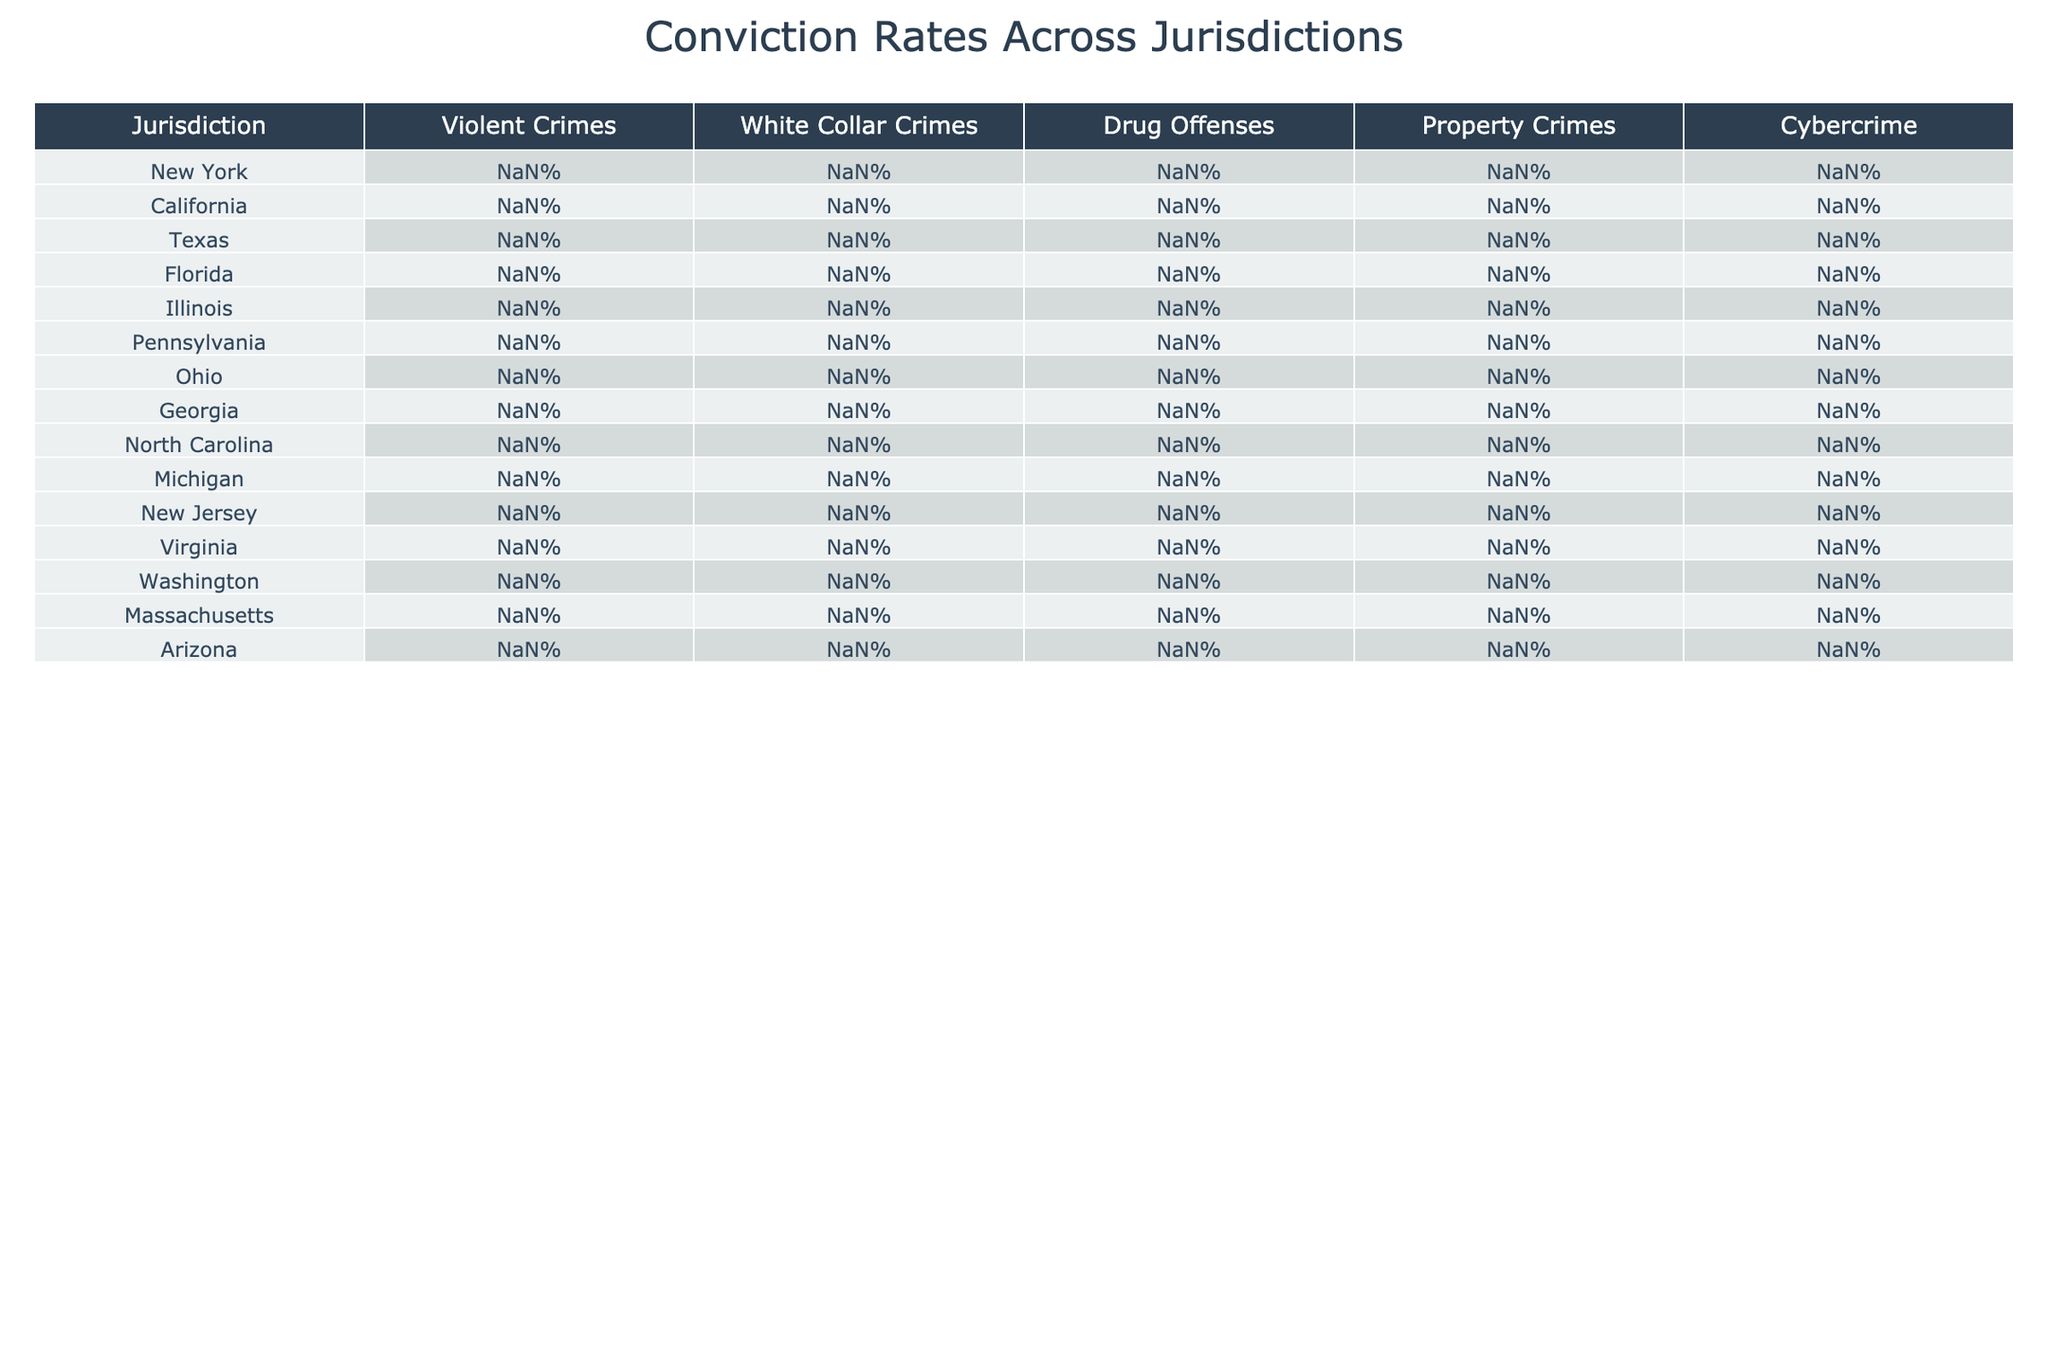What is the conviction rate for violent crimes in Texas? The table shows that the conviction rate for violent crimes in Texas is 81%.
Answer: 81% Which jurisdiction has the highest conviction rate for drug offenses? By examining the table, Texas has the highest conviction rate for drug offenses at 88%.
Answer: Texas What is the average conviction rate for property crimes across all jurisdictions listed? Adding the conviction rates for property crimes (71 + 68 + 74 + 70 + 69 + 72 + 73 + 71 + 70 + 68 + 69 + 72 + 67 + 69 + 73) gives a total of 1,056. There are 15 jurisdictions, so the average is 1,056 / 15 = 70.4%.
Answer: 70.4% Is the conviction rate for white collar crimes in California higher than in New York? California's conviction rate for white collar crimes is 59%, while New York's is 62%. Since 59% is less than 62%, the answer is no.
Answer: No Which type of crime has the lowest conviction rate in New Jersey? In the table, the conviction rate for cybercrime in New Jersey is 61%, which is lower than all other rates listed for New Jersey.
Answer: Cybercrime If we consider the median conviction rate for cybercrime across all jurisdictions, what would it be? Arranging the cybercrime conviction rates (58%, 63%, 55%, 60%, 57%, 62%, 59%, 54%, 58%, 61%, 56%, 59%, 58%, 57%, 56%) in ascending order gives us 54%, 55%, 56%, 56%, 57%, 57%, 58%, 58%, 58%, 59%, 59%, 60%, 61%, 62%, 63%. The median (the middle value in the ordered list) for 15 values is the 8th value, which is 58%.
Answer: 58% Which jurisdiction has the closest conviction rate for property crimes to the average across all listed jurisdictions? The average conviction rate for property crimes is 70.4%. Looking at the table, both Florida (70%) and Michigan (68%) are close, but Florida's 70% is slightly closer than Michigan's 68%.
Answer: Florida Are there any jurisdictions where the conviction rate for drug offenses exceeds the rate for property crimes? By comparing the rates, New York (85% vs 71%), Texas (88% vs 74%), Florida (84% vs 70%), Pennsylvania (86% vs 72%), Ohio (87% vs 73%), North Carolina (84% vs 70%), and Arizona (87% vs 73%) all have drug offense rates that exceed property crime rates. Thus, the answer is yes.
Answer: Yes What is the difference in conviction rates for violent crimes between Georgia and New York? Georgia's conviction rate for violent crimes is 80%, while New York's is 78%. The difference is 80% - 78% = 2%.
Answer: 2% 